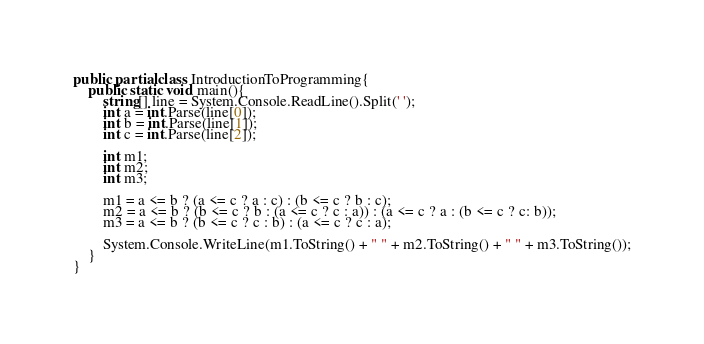Convert code to text. <code><loc_0><loc_0><loc_500><loc_500><_C#_>public partial class IntroductionToProgramming{
	public static void main(){
		string[] line = System.Console.ReadLine().Split(' ');
		int a = int.Parse(line[0]);
		int b = int.Parse(line[1]);
		int c = int.Parse(line[2]);
		
		int m1;
		int m2;
		int m3;

		m1 = a <= b ? (a <= c ? a : c) : (b <= c ? b : c);
		m2 = a <= b ? (b <= c ? b : (a <= c ? c : a)) : (a <= c ? a : (b <= c ? c: b));
		m3 = a <= b ? (b <= c ? c : b) : (a <= c ? c : a);

		System.Console.WriteLine(m1.ToString() + " " + m2.ToString() + " " + m3.ToString());
	}
}</code> 